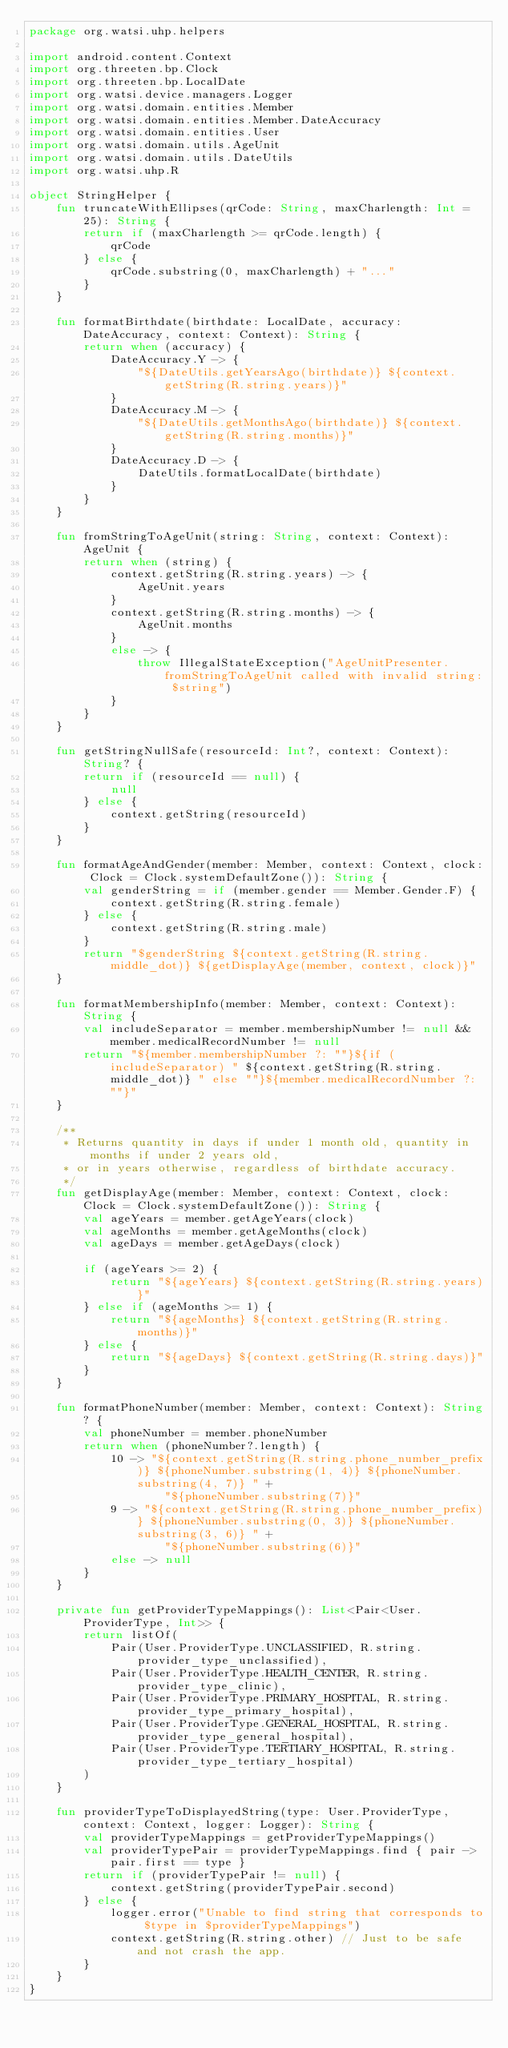<code> <loc_0><loc_0><loc_500><loc_500><_Kotlin_>package org.watsi.uhp.helpers

import android.content.Context
import org.threeten.bp.Clock
import org.threeten.bp.LocalDate
import org.watsi.device.managers.Logger
import org.watsi.domain.entities.Member
import org.watsi.domain.entities.Member.DateAccuracy
import org.watsi.domain.entities.User
import org.watsi.domain.utils.AgeUnit
import org.watsi.domain.utils.DateUtils
import org.watsi.uhp.R

object StringHelper {
    fun truncateWithEllipses(qrCode: String, maxCharlength: Int = 25): String {
        return if (maxCharlength >= qrCode.length) {
            qrCode
        } else {
            qrCode.substring(0, maxCharlength) + "..."
        }
    }

    fun formatBirthdate(birthdate: LocalDate, accuracy: DateAccuracy, context: Context): String {
        return when (accuracy) {
            DateAccuracy.Y -> {
                "${DateUtils.getYearsAgo(birthdate)} ${context.getString(R.string.years)}"
            }
            DateAccuracy.M -> {
                "${DateUtils.getMonthsAgo(birthdate)} ${context.getString(R.string.months)}"
            }
            DateAccuracy.D -> {
                DateUtils.formatLocalDate(birthdate)
            }
        }
    }

    fun fromStringToAgeUnit(string: String, context: Context): AgeUnit {
        return when (string) {
            context.getString(R.string.years) -> {
                AgeUnit.years
            }
            context.getString(R.string.months) -> {
                AgeUnit.months
            }
            else -> {
                throw IllegalStateException("AgeUnitPresenter.fromStringToAgeUnit called with invalid string: $string")
            }
        }
    }

    fun getStringNullSafe(resourceId: Int?, context: Context): String? {
        return if (resourceId == null) {
            null
        } else {
            context.getString(resourceId)
        }
    }

    fun formatAgeAndGender(member: Member, context: Context, clock: Clock = Clock.systemDefaultZone()): String {
        val genderString = if (member.gender == Member.Gender.F) {
            context.getString(R.string.female)
        } else {
            context.getString(R.string.male)
        }
        return "$genderString ${context.getString(R.string.middle_dot)} ${getDisplayAge(member, context, clock)}"
    }

    fun formatMembershipInfo(member: Member, context: Context): String {
        val includeSeparator = member.membershipNumber != null && member.medicalRecordNumber != null
        return "${member.membershipNumber ?: ""}${if (includeSeparator) " ${context.getString(R.string.middle_dot)} " else ""}${member.medicalRecordNumber ?: ""}"
    }

    /**
     * Returns quantity in days if under 1 month old, quantity in months if under 2 years old,
     * or in years otherwise, regardless of birthdate accuracy.
     */
    fun getDisplayAge(member: Member, context: Context, clock: Clock = Clock.systemDefaultZone()): String {
        val ageYears = member.getAgeYears(clock)
        val ageMonths = member.getAgeMonths(clock)
        val ageDays = member.getAgeDays(clock)

        if (ageYears >= 2) {
            return "${ageYears} ${context.getString(R.string.years)}"
        } else if (ageMonths >= 1) {
            return "${ageMonths} ${context.getString(R.string.months)}"
        } else {
            return "${ageDays} ${context.getString(R.string.days)}"
        }
    }

    fun formatPhoneNumber(member: Member, context: Context): String? {
        val phoneNumber = member.phoneNumber
        return when (phoneNumber?.length) {
            10 -> "${context.getString(R.string.phone_number_prefix)} ${phoneNumber.substring(1, 4)} ${phoneNumber.substring(4, 7)} " +
                    "${phoneNumber.substring(7)}"
            9 -> "${context.getString(R.string.phone_number_prefix)} ${phoneNumber.substring(0, 3)} ${phoneNumber.substring(3, 6)} " +
                    "${phoneNumber.substring(6)}"
            else -> null
        }
    }

    private fun getProviderTypeMappings(): List<Pair<User.ProviderType, Int>> {
        return listOf(
            Pair(User.ProviderType.UNCLASSIFIED, R.string.provider_type_unclassified),
            Pair(User.ProviderType.HEALTH_CENTER, R.string.provider_type_clinic),
            Pair(User.ProviderType.PRIMARY_HOSPITAL, R.string.provider_type_primary_hospital),
            Pair(User.ProviderType.GENERAL_HOSPITAL, R.string.provider_type_general_hospital),
            Pair(User.ProviderType.TERTIARY_HOSPITAL, R.string.provider_type_tertiary_hospital)
        )
    }

    fun providerTypeToDisplayedString(type: User.ProviderType, context: Context, logger: Logger): String {
        val providerTypeMappings = getProviderTypeMappings()
        val providerTypePair = providerTypeMappings.find { pair -> pair.first == type }
        return if (providerTypePair != null) {
            context.getString(providerTypePair.second)
        } else {
            logger.error("Unable to find string that corresponds to $type in $providerTypeMappings")
            context.getString(R.string.other) // Just to be safe and not crash the app.
        }
    }
}
</code> 